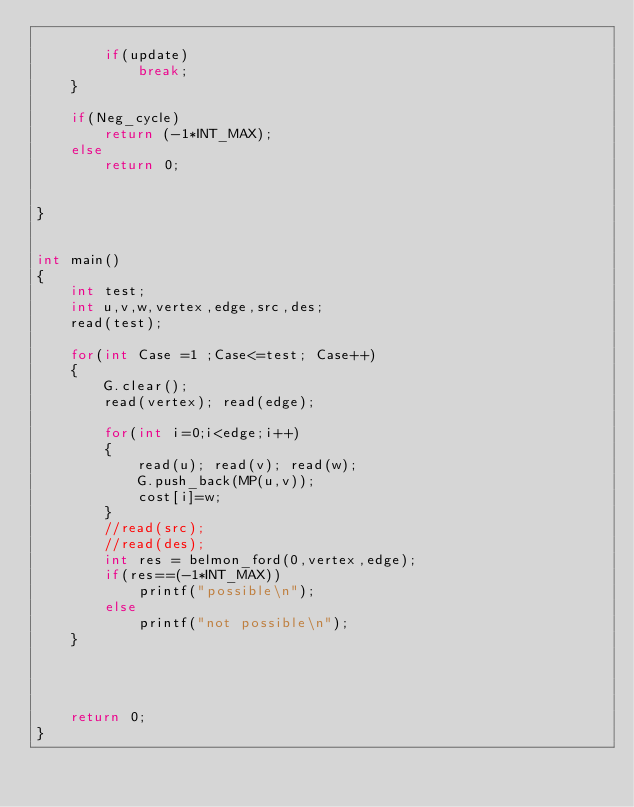<code> <loc_0><loc_0><loc_500><loc_500><_C++_>
        if(update)
            break;
    }

    if(Neg_cycle)
        return (-1*INT_MAX);
    else
        return 0;


}


int main()
{
    int test;
    int u,v,w,vertex,edge,src,des;
    read(test);

    for(int Case =1 ;Case<=test; Case++)
    {
        G.clear();
        read(vertex); read(edge);

        for(int i=0;i<edge;i++)
        {
            read(u); read(v); read(w);
            G.push_back(MP(u,v));
            cost[i]=w;
        }
        //read(src);
        //read(des);
        int res = belmon_ford(0,vertex,edge);
        if(res==(-1*INT_MAX))
            printf("possible\n");
        else
            printf("not possible\n");
    }




    return 0;
}
</code> 